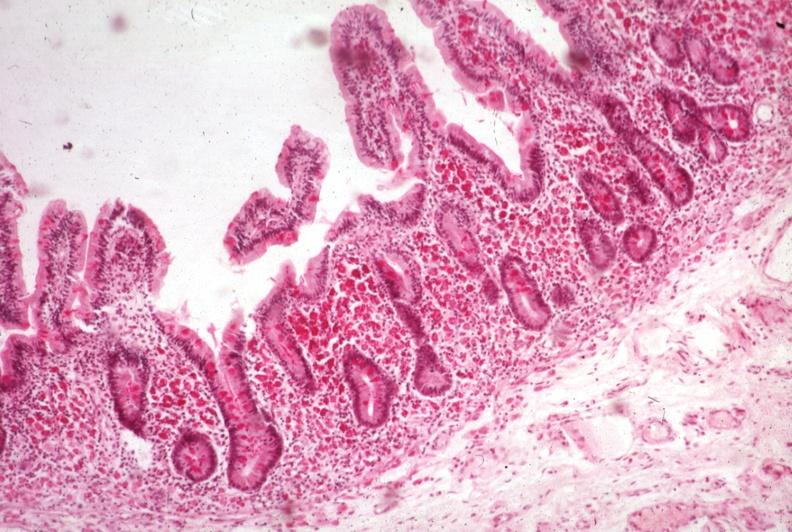what is present?
Answer the question using a single word or phrase. Intestine 